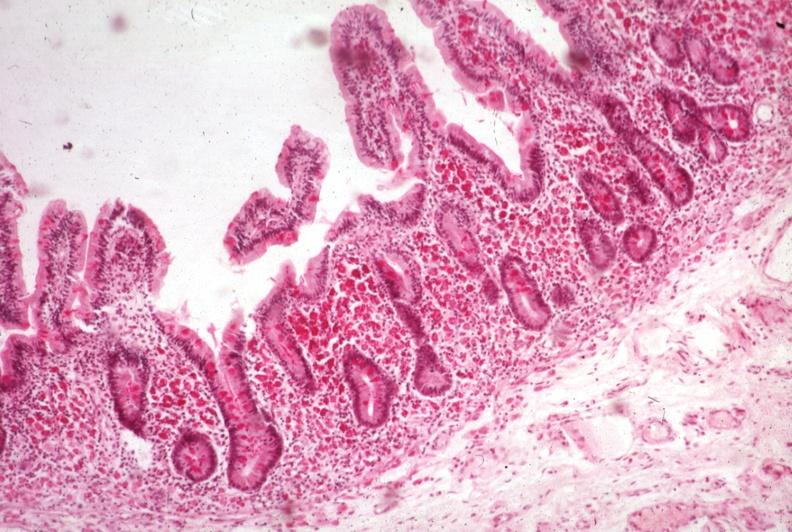what is present?
Answer the question using a single word or phrase. Intestine 